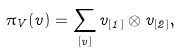<formula> <loc_0><loc_0><loc_500><loc_500>\pi _ { V } ( v ) = \sum _ { [ v ] } v _ { [ 1 ] } \otimes v _ { [ 2 ] } ,</formula> 